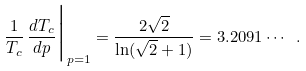Convert formula to latex. <formula><loc_0><loc_0><loc_500><loc_500>\frac { 1 } { T _ { c } } \, \frac { d T _ { c } } { d p } \Big | _ { p = 1 } = \frac { 2 \sqrt { 2 } } { \ln ( \sqrt { 2 } + 1 ) } = 3 . 2 0 9 1 \cdots \ .</formula> 